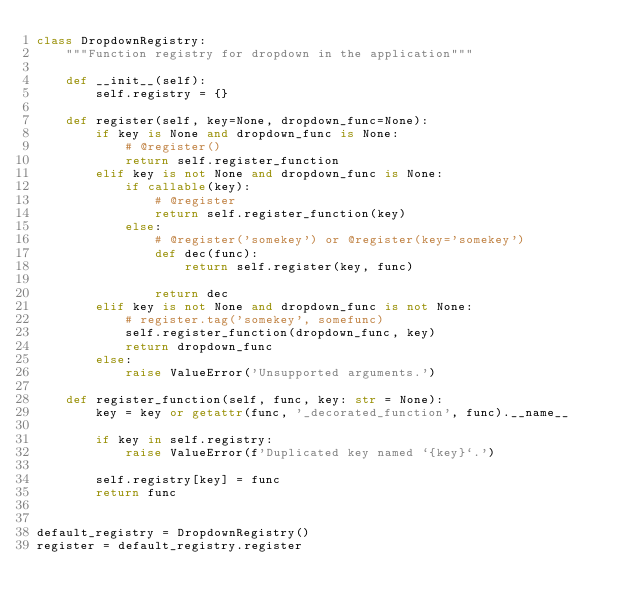<code> <loc_0><loc_0><loc_500><loc_500><_Python_>class DropdownRegistry:
    """Function registry for dropdown in the application"""

    def __init__(self):
        self.registry = {}

    def register(self, key=None, dropdown_func=None):
        if key is None and dropdown_func is None:
            # @register()
            return self.register_function
        elif key is not None and dropdown_func is None:
            if callable(key):
                # @register
                return self.register_function(key)
            else:
                # @register('somekey') or @register(key='somekey')
                def dec(func):
                    return self.register(key, func)

                return dec
        elif key is not None and dropdown_func is not None:
            # register.tag('somekey', somefunc)
            self.register_function(dropdown_func, key)
            return dropdown_func
        else:
            raise ValueError('Unsupported arguments.')

    def register_function(self, func, key: str = None):
        key = key or getattr(func, '_decorated_function', func).__name__

        if key in self.registry:
            raise ValueError(f'Duplicated key named `{key}`.')

        self.registry[key] = func
        return func


default_registry = DropdownRegistry()
register = default_registry.register
</code> 